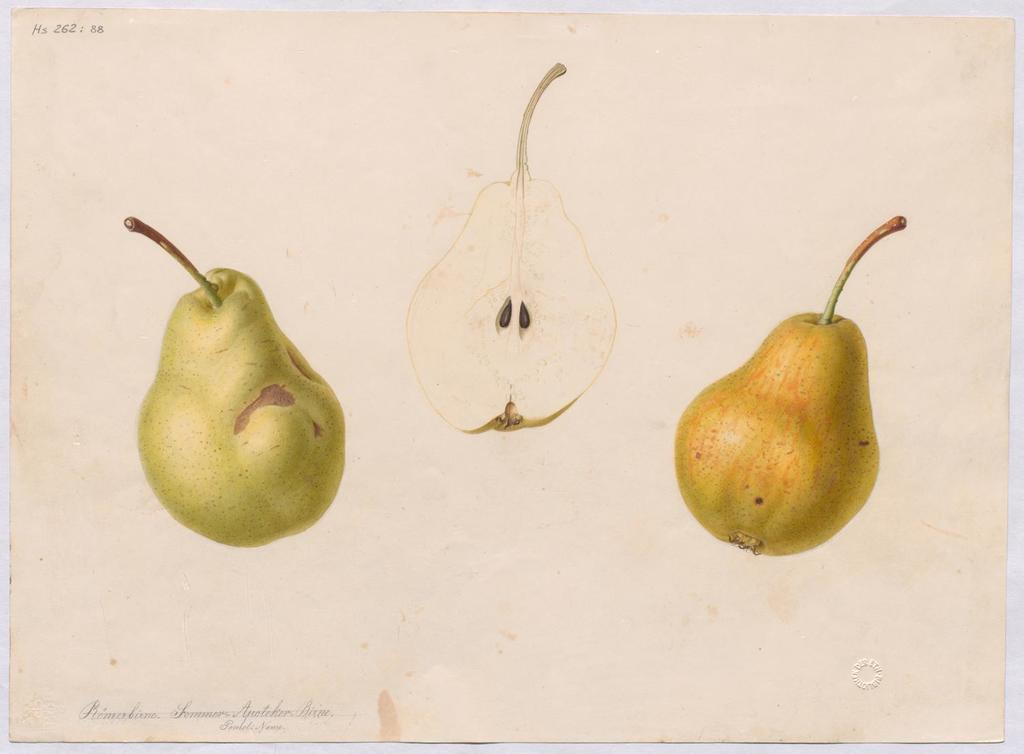What is depicted on the paper in the image? The paper contains drawings of avocado. What is written or printed at the bottom of the paper? There is text at the bottom of the paper. How does the eggnog selection appear in the image? There is no eggnog selection present in the image. What type of push is demonstrated by the avocado drawings in the image? The avocado drawings do not demonstrate any type of push; they are simply drawings of avocado. 